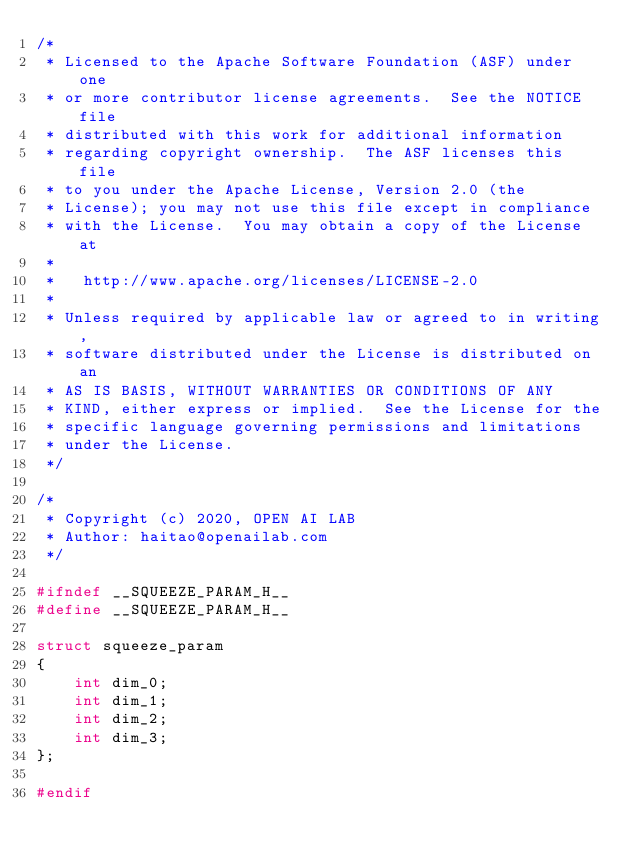<code> <loc_0><loc_0><loc_500><loc_500><_C_>/*
 * Licensed to the Apache Software Foundation (ASF) under one
 * or more contributor license agreements.  See the NOTICE file
 * distributed with this work for additional information
 * regarding copyright ownership.  The ASF licenses this file
 * to you under the Apache License, Version 2.0 (the
 * License); you may not use this file except in compliance
 * with the License.  You may obtain a copy of the License at
 *
 *   http://www.apache.org/licenses/LICENSE-2.0
 *
 * Unless required by applicable law or agreed to in writing,
 * software distributed under the License is distributed on an
 * AS IS BASIS, WITHOUT WARRANTIES OR CONDITIONS OF ANY
 * KIND, either express or implied.  See the License for the
 * specific language governing permissions and limitations
 * under the License.
 */

/*
 * Copyright (c) 2020, OPEN AI LAB
 * Author: haitao@openailab.com
 */

#ifndef __SQUEEZE_PARAM_H__
#define __SQUEEZE_PARAM_H__

struct squeeze_param
{
    int dim_0;
    int dim_1;
    int dim_2;
    int dim_3;
};

#endif
</code> 